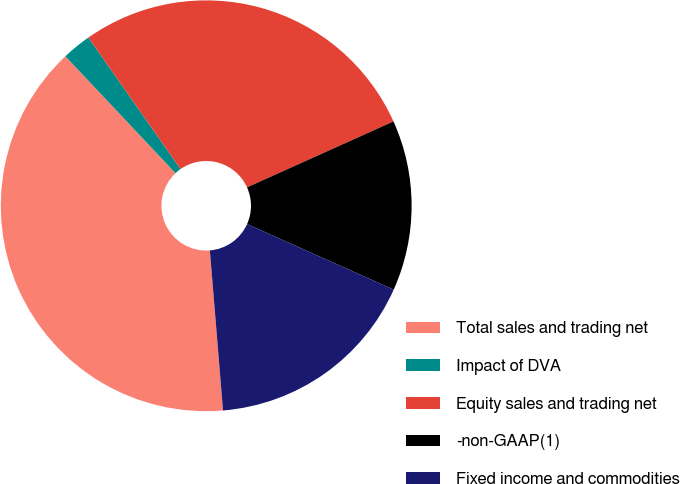Convert chart to OTSL. <chart><loc_0><loc_0><loc_500><loc_500><pie_chart><fcel>Total sales and trading net<fcel>Impact of DVA<fcel>Equity sales and trading net<fcel>-non-GAAP(1)<fcel>Fixed income and commodities<nl><fcel>39.28%<fcel>2.3%<fcel>27.99%<fcel>13.43%<fcel>17.0%<nl></chart> 